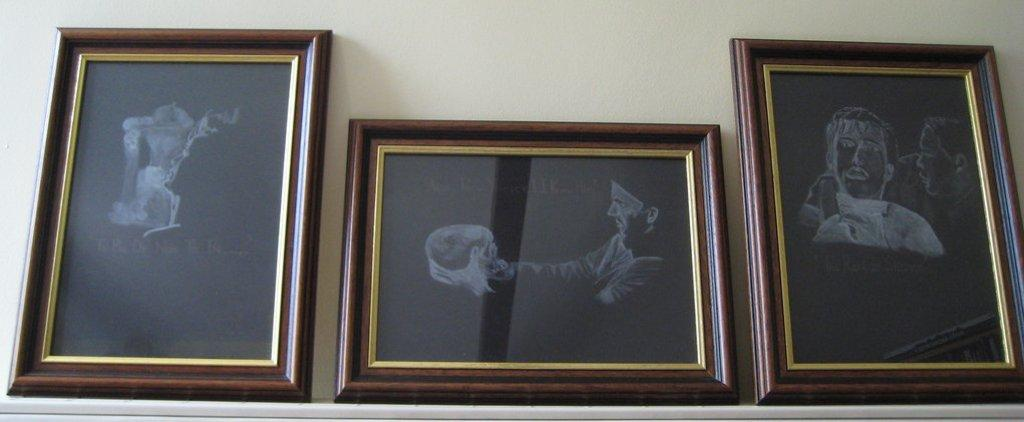What objects can be seen in the image? There are photo frames in the image. Where are the photo frames located? The photo frames are on a surface. What can be seen behind the photo frames? There is a wall visible behind the photo frames. What type of plantation can be seen growing near the photo frames in the image? There is no plantation present in the image; it only features photo frames on a surface with a wall visible behind them. 